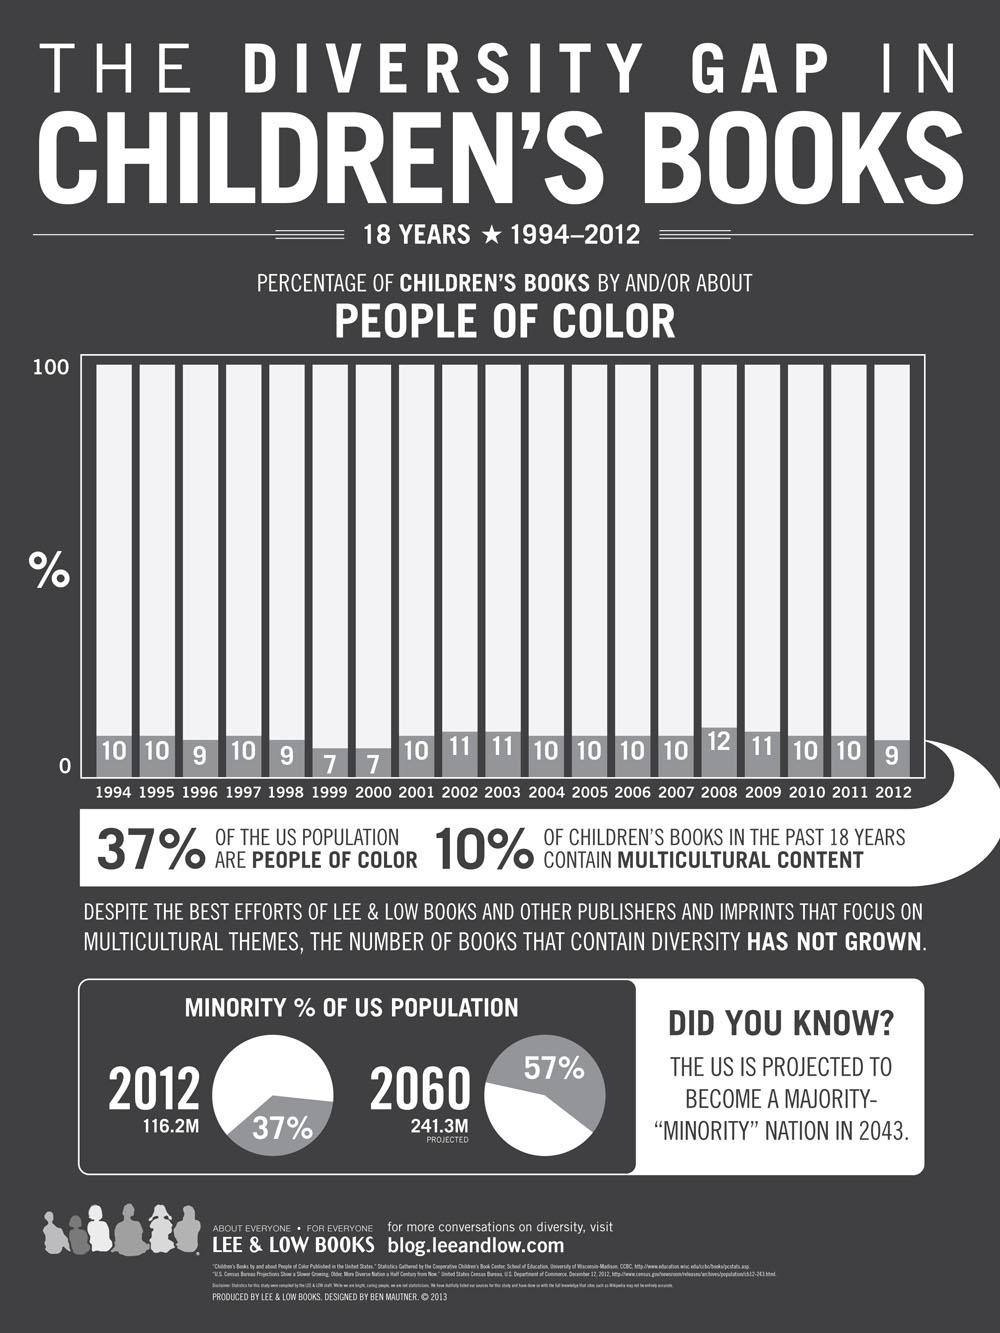Specify some key components in this picture. Ninety percent of children's books do not contain multicultural content. According to data, approximately 63% of the US population is composed of colored people. In the years 1996, 1998, and 2012, the percentage of children's books that featured characters of color was approximately the same. The highest percentage of children's books about people of color is 12%. 